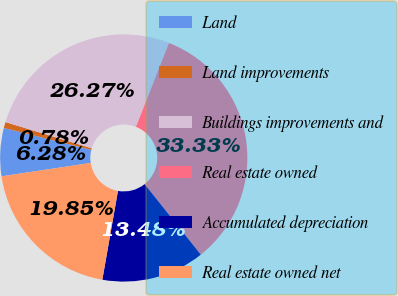<chart> <loc_0><loc_0><loc_500><loc_500><pie_chart><fcel>Land<fcel>Land improvements<fcel>Buildings improvements and<fcel>Real estate owned<fcel>Accumulated depreciation<fcel>Real estate owned net<nl><fcel>6.28%<fcel>0.78%<fcel>26.27%<fcel>33.33%<fcel>13.48%<fcel>19.85%<nl></chart> 